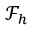Convert formula to latex. <formula><loc_0><loc_0><loc_500><loc_500>\mathcal { F } _ { h }</formula> 